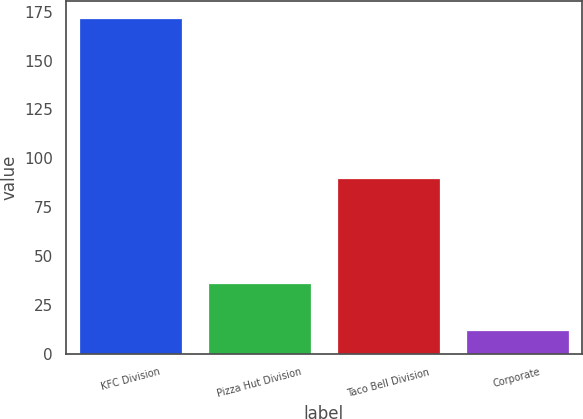<chart> <loc_0><loc_0><loc_500><loc_500><bar_chart><fcel>KFC Division<fcel>Pizza Hut Division<fcel>Taco Bell Division<fcel>Corporate<nl><fcel>172<fcel>36<fcel>90<fcel>12<nl></chart> 